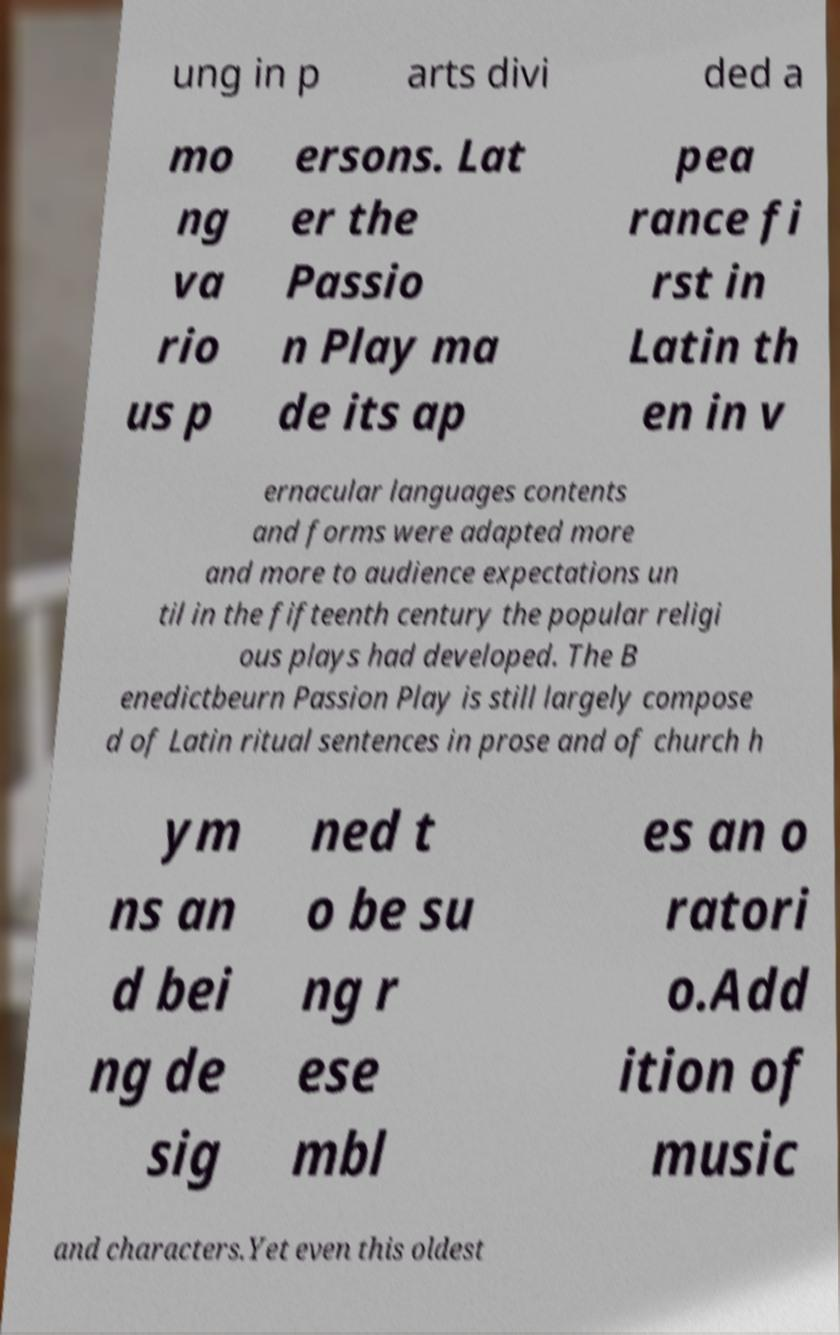Could you assist in decoding the text presented in this image and type it out clearly? ung in p arts divi ded a mo ng va rio us p ersons. Lat er the Passio n Play ma de its ap pea rance fi rst in Latin th en in v ernacular languages contents and forms were adapted more and more to audience expectations un til in the fifteenth century the popular religi ous plays had developed. The B enedictbeurn Passion Play is still largely compose d of Latin ritual sentences in prose and of church h ym ns an d bei ng de sig ned t o be su ng r ese mbl es an o ratori o.Add ition of music and characters.Yet even this oldest 